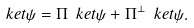Convert formula to latex. <formula><loc_0><loc_0><loc_500><loc_500>\ k e t { \psi } = \Pi \ k e t { \psi } + \Pi ^ { \perp } \ k e t { \psi } .</formula> 